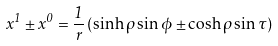<formula> <loc_0><loc_0><loc_500><loc_500>x ^ { 1 } \pm x ^ { 0 } = \frac { 1 } { r } \left ( \sinh \rho \sin \phi \pm \cosh \rho \sin \tau \right )</formula> 